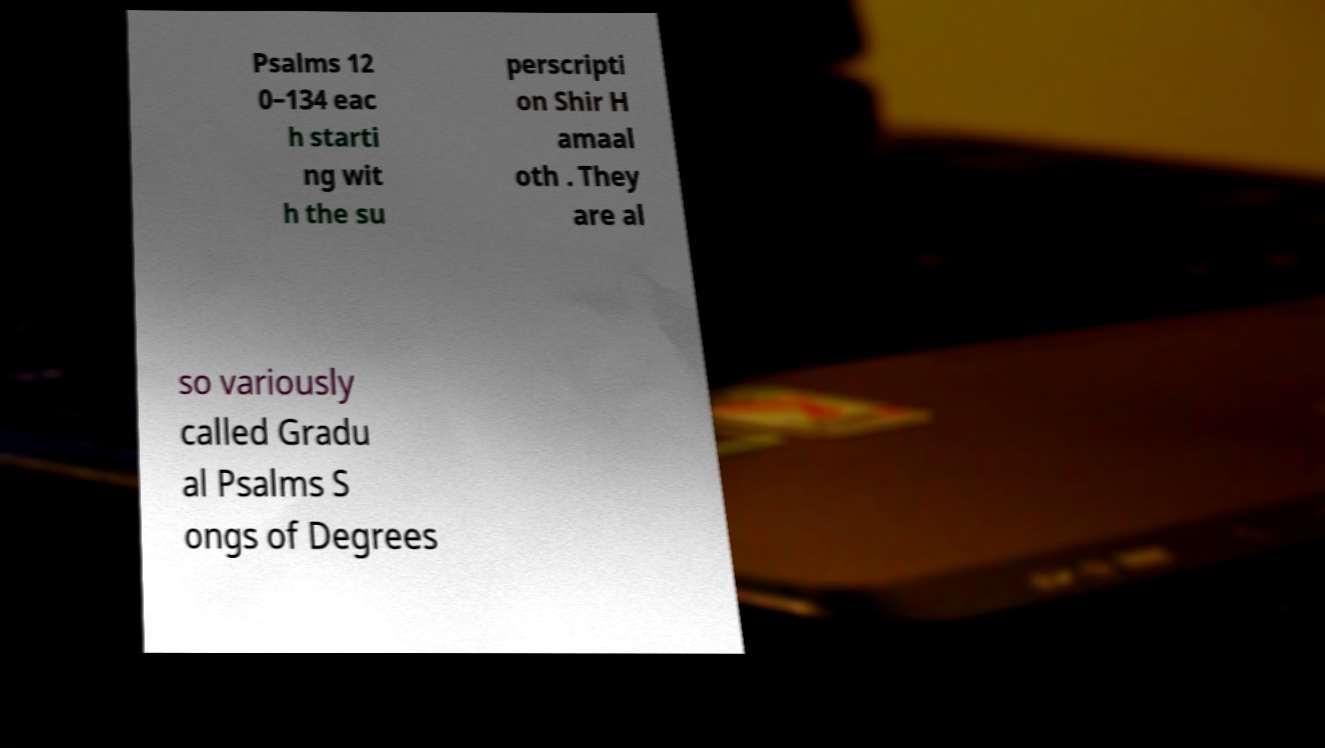Can you accurately transcribe the text from the provided image for me? Psalms 12 0–134 eac h starti ng wit h the su perscripti on Shir H amaal oth . They are al so variously called Gradu al Psalms S ongs of Degrees 